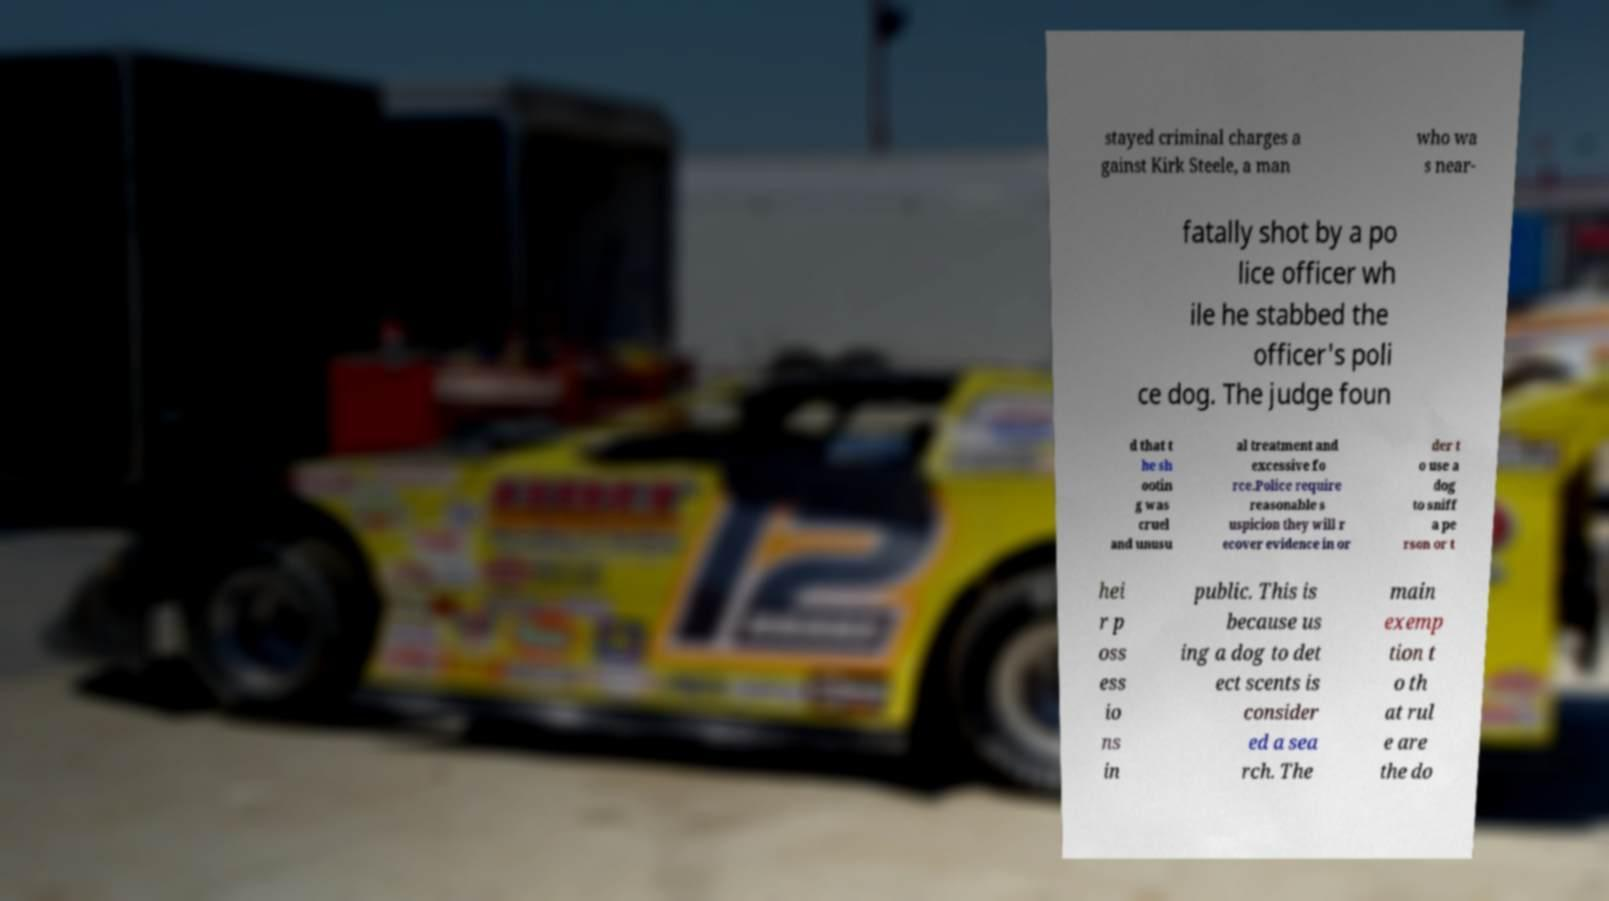For documentation purposes, I need the text within this image transcribed. Could you provide that? stayed criminal charges a gainst Kirk Steele, a man who wa s near- fatally shot by a po lice officer wh ile he stabbed the officer's poli ce dog. The judge foun d that t he sh ootin g was cruel and unusu al treatment and excessive fo rce.Police require reasonable s uspicion they will r ecover evidence in or der t o use a dog to sniff a pe rson or t hei r p oss ess io ns in public. This is because us ing a dog to det ect scents is consider ed a sea rch. The main exemp tion t o th at rul e are the do 